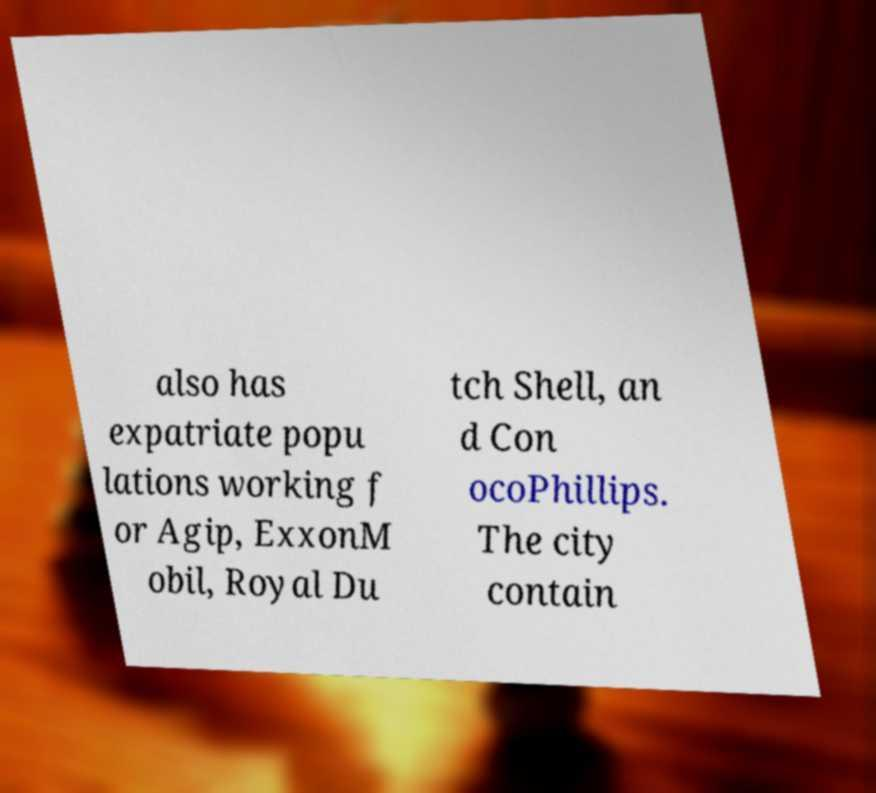I need the written content from this picture converted into text. Can you do that? also has expatriate popu lations working f or Agip, ExxonM obil, Royal Du tch Shell, an d Con ocoPhillips. The city contain 